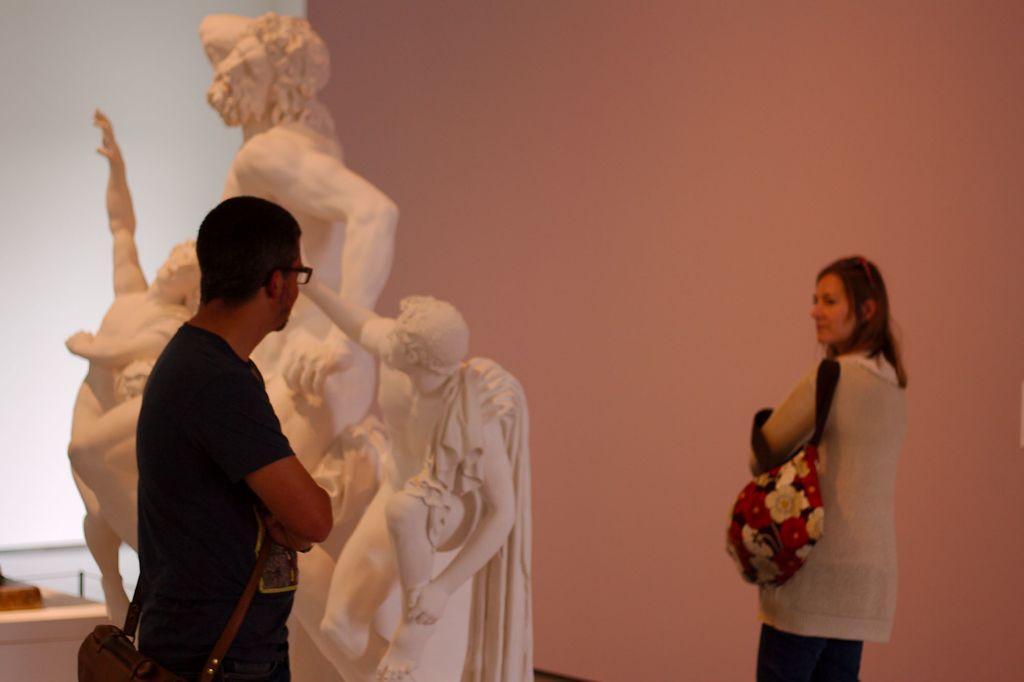Can you describe this image briefly? In this image in front there are two persons standing on the floor. Behind them there is a statue. On the backside there is a wall. 